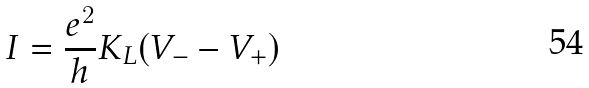<formula> <loc_0><loc_0><loc_500><loc_500>I = \frac { e ^ { 2 } } { h } K _ { L } ( V _ { - } - V _ { + } )</formula> 